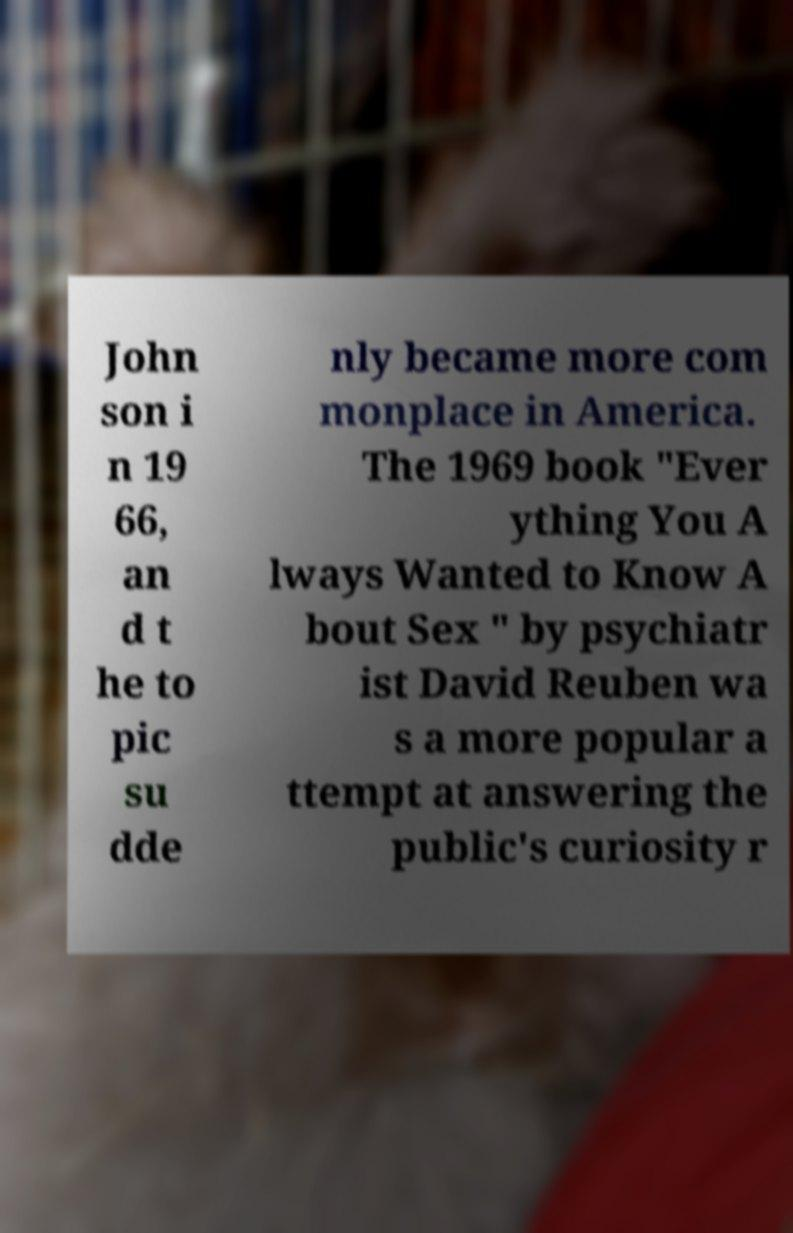What messages or text are displayed in this image? I need them in a readable, typed format. John son i n 19 66, an d t he to pic su dde nly became more com monplace in America. The 1969 book "Ever ything You A lways Wanted to Know A bout Sex " by psychiatr ist David Reuben wa s a more popular a ttempt at answering the public's curiosity r 